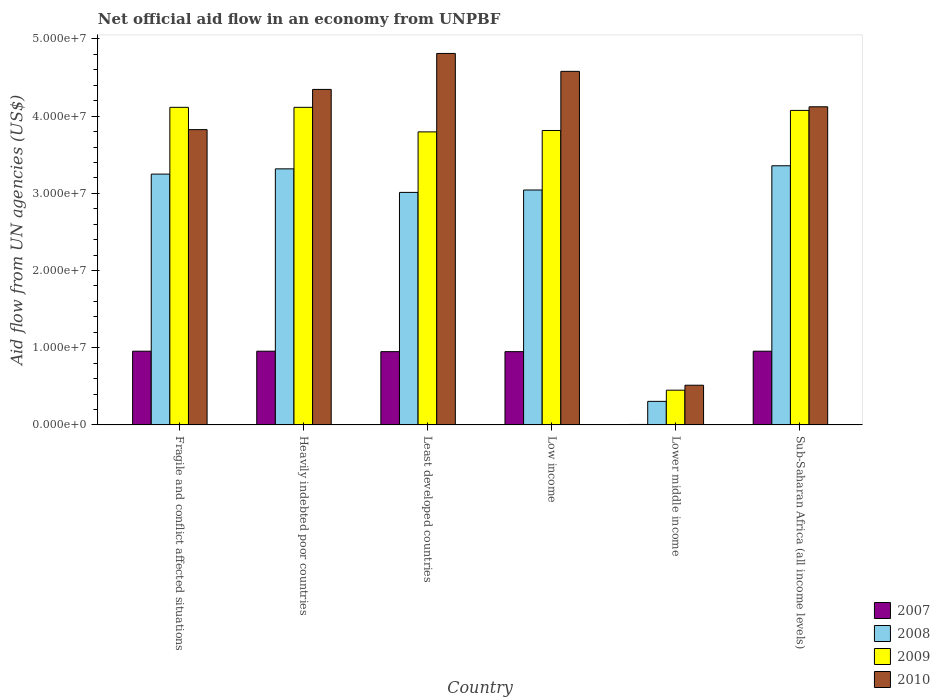Are the number of bars on each tick of the X-axis equal?
Your response must be concise. Yes. How many bars are there on the 5th tick from the left?
Keep it short and to the point. 4. How many bars are there on the 5th tick from the right?
Offer a very short reply. 4. What is the label of the 2nd group of bars from the left?
Your answer should be compact. Heavily indebted poor countries. In how many cases, is the number of bars for a given country not equal to the number of legend labels?
Provide a succinct answer. 0. What is the net official aid flow in 2007 in Sub-Saharan Africa (all income levels)?
Offer a terse response. 9.55e+06. Across all countries, what is the maximum net official aid flow in 2010?
Make the answer very short. 4.81e+07. Across all countries, what is the minimum net official aid flow in 2008?
Your answer should be very brief. 3.05e+06. In which country was the net official aid flow in 2010 maximum?
Keep it short and to the point. Least developed countries. In which country was the net official aid flow in 2010 minimum?
Ensure brevity in your answer.  Lower middle income. What is the total net official aid flow in 2010 in the graph?
Offer a very short reply. 2.22e+08. What is the difference between the net official aid flow in 2010 in Fragile and conflict affected situations and that in Lower middle income?
Your response must be concise. 3.31e+07. What is the difference between the net official aid flow in 2010 in Sub-Saharan Africa (all income levels) and the net official aid flow in 2007 in Lower middle income?
Your answer should be very brief. 4.12e+07. What is the average net official aid flow in 2010 per country?
Your answer should be very brief. 3.70e+07. What is the difference between the net official aid flow of/in 2009 and net official aid flow of/in 2008 in Sub-Saharan Africa (all income levels)?
Your response must be concise. 7.17e+06. What is the ratio of the net official aid flow in 2008 in Heavily indebted poor countries to that in Least developed countries?
Ensure brevity in your answer.  1.1. Is the net official aid flow in 2008 in Low income less than that in Sub-Saharan Africa (all income levels)?
Your response must be concise. Yes. Is the difference between the net official aid flow in 2009 in Fragile and conflict affected situations and Least developed countries greater than the difference between the net official aid flow in 2008 in Fragile and conflict affected situations and Least developed countries?
Keep it short and to the point. Yes. What is the difference between the highest and the second highest net official aid flow in 2010?
Give a very brief answer. 2.32e+06. What is the difference between the highest and the lowest net official aid flow in 2008?
Offer a very short reply. 3.05e+07. Is it the case that in every country, the sum of the net official aid flow in 2007 and net official aid flow in 2008 is greater than the sum of net official aid flow in 2010 and net official aid flow in 2009?
Make the answer very short. No. Is it the case that in every country, the sum of the net official aid flow in 2010 and net official aid flow in 2008 is greater than the net official aid flow in 2009?
Provide a succinct answer. Yes. Are all the bars in the graph horizontal?
Your response must be concise. No. Are the values on the major ticks of Y-axis written in scientific E-notation?
Your answer should be compact. Yes. Does the graph contain any zero values?
Ensure brevity in your answer.  No. Where does the legend appear in the graph?
Provide a succinct answer. Bottom right. What is the title of the graph?
Offer a terse response. Net official aid flow in an economy from UNPBF. Does "1983" appear as one of the legend labels in the graph?
Your response must be concise. No. What is the label or title of the X-axis?
Provide a short and direct response. Country. What is the label or title of the Y-axis?
Ensure brevity in your answer.  Aid flow from UN agencies (US$). What is the Aid flow from UN agencies (US$) of 2007 in Fragile and conflict affected situations?
Keep it short and to the point. 9.55e+06. What is the Aid flow from UN agencies (US$) in 2008 in Fragile and conflict affected situations?
Offer a very short reply. 3.25e+07. What is the Aid flow from UN agencies (US$) of 2009 in Fragile and conflict affected situations?
Offer a terse response. 4.11e+07. What is the Aid flow from UN agencies (US$) of 2010 in Fragile and conflict affected situations?
Give a very brief answer. 3.82e+07. What is the Aid flow from UN agencies (US$) in 2007 in Heavily indebted poor countries?
Provide a short and direct response. 9.55e+06. What is the Aid flow from UN agencies (US$) of 2008 in Heavily indebted poor countries?
Offer a very short reply. 3.32e+07. What is the Aid flow from UN agencies (US$) of 2009 in Heavily indebted poor countries?
Offer a very short reply. 4.11e+07. What is the Aid flow from UN agencies (US$) in 2010 in Heavily indebted poor countries?
Keep it short and to the point. 4.35e+07. What is the Aid flow from UN agencies (US$) of 2007 in Least developed countries?
Offer a terse response. 9.49e+06. What is the Aid flow from UN agencies (US$) of 2008 in Least developed countries?
Offer a very short reply. 3.01e+07. What is the Aid flow from UN agencies (US$) in 2009 in Least developed countries?
Offer a terse response. 3.80e+07. What is the Aid flow from UN agencies (US$) of 2010 in Least developed countries?
Offer a very short reply. 4.81e+07. What is the Aid flow from UN agencies (US$) of 2007 in Low income?
Give a very brief answer. 9.49e+06. What is the Aid flow from UN agencies (US$) in 2008 in Low income?
Provide a short and direct response. 3.04e+07. What is the Aid flow from UN agencies (US$) in 2009 in Low income?
Ensure brevity in your answer.  3.81e+07. What is the Aid flow from UN agencies (US$) in 2010 in Low income?
Provide a short and direct response. 4.58e+07. What is the Aid flow from UN agencies (US$) in 2008 in Lower middle income?
Your answer should be compact. 3.05e+06. What is the Aid flow from UN agencies (US$) in 2009 in Lower middle income?
Provide a succinct answer. 4.50e+06. What is the Aid flow from UN agencies (US$) in 2010 in Lower middle income?
Your answer should be compact. 5.14e+06. What is the Aid flow from UN agencies (US$) of 2007 in Sub-Saharan Africa (all income levels)?
Your answer should be compact. 9.55e+06. What is the Aid flow from UN agencies (US$) of 2008 in Sub-Saharan Africa (all income levels)?
Provide a succinct answer. 3.36e+07. What is the Aid flow from UN agencies (US$) in 2009 in Sub-Saharan Africa (all income levels)?
Provide a short and direct response. 4.07e+07. What is the Aid flow from UN agencies (US$) of 2010 in Sub-Saharan Africa (all income levels)?
Your answer should be compact. 4.12e+07. Across all countries, what is the maximum Aid flow from UN agencies (US$) of 2007?
Offer a very short reply. 9.55e+06. Across all countries, what is the maximum Aid flow from UN agencies (US$) of 2008?
Make the answer very short. 3.36e+07. Across all countries, what is the maximum Aid flow from UN agencies (US$) in 2009?
Your answer should be compact. 4.11e+07. Across all countries, what is the maximum Aid flow from UN agencies (US$) in 2010?
Your answer should be compact. 4.81e+07. Across all countries, what is the minimum Aid flow from UN agencies (US$) in 2007?
Ensure brevity in your answer.  6.00e+04. Across all countries, what is the minimum Aid flow from UN agencies (US$) of 2008?
Make the answer very short. 3.05e+06. Across all countries, what is the minimum Aid flow from UN agencies (US$) of 2009?
Your response must be concise. 4.50e+06. Across all countries, what is the minimum Aid flow from UN agencies (US$) in 2010?
Your answer should be very brief. 5.14e+06. What is the total Aid flow from UN agencies (US$) in 2007 in the graph?
Make the answer very short. 4.77e+07. What is the total Aid flow from UN agencies (US$) of 2008 in the graph?
Provide a short and direct response. 1.63e+08. What is the total Aid flow from UN agencies (US$) in 2009 in the graph?
Ensure brevity in your answer.  2.04e+08. What is the total Aid flow from UN agencies (US$) of 2010 in the graph?
Offer a very short reply. 2.22e+08. What is the difference between the Aid flow from UN agencies (US$) in 2007 in Fragile and conflict affected situations and that in Heavily indebted poor countries?
Your response must be concise. 0. What is the difference between the Aid flow from UN agencies (US$) of 2008 in Fragile and conflict affected situations and that in Heavily indebted poor countries?
Offer a terse response. -6.80e+05. What is the difference between the Aid flow from UN agencies (US$) of 2010 in Fragile and conflict affected situations and that in Heavily indebted poor countries?
Make the answer very short. -5.21e+06. What is the difference between the Aid flow from UN agencies (US$) of 2008 in Fragile and conflict affected situations and that in Least developed countries?
Provide a short and direct response. 2.37e+06. What is the difference between the Aid flow from UN agencies (US$) in 2009 in Fragile and conflict affected situations and that in Least developed countries?
Offer a terse response. 3.18e+06. What is the difference between the Aid flow from UN agencies (US$) of 2010 in Fragile and conflict affected situations and that in Least developed countries?
Your answer should be compact. -9.87e+06. What is the difference between the Aid flow from UN agencies (US$) in 2008 in Fragile and conflict affected situations and that in Low income?
Make the answer very short. 2.06e+06. What is the difference between the Aid flow from UN agencies (US$) in 2010 in Fragile and conflict affected situations and that in Low income?
Provide a short and direct response. -7.55e+06. What is the difference between the Aid flow from UN agencies (US$) of 2007 in Fragile and conflict affected situations and that in Lower middle income?
Provide a succinct answer. 9.49e+06. What is the difference between the Aid flow from UN agencies (US$) in 2008 in Fragile and conflict affected situations and that in Lower middle income?
Keep it short and to the point. 2.94e+07. What is the difference between the Aid flow from UN agencies (US$) in 2009 in Fragile and conflict affected situations and that in Lower middle income?
Ensure brevity in your answer.  3.66e+07. What is the difference between the Aid flow from UN agencies (US$) in 2010 in Fragile and conflict affected situations and that in Lower middle income?
Your answer should be compact. 3.31e+07. What is the difference between the Aid flow from UN agencies (US$) of 2007 in Fragile and conflict affected situations and that in Sub-Saharan Africa (all income levels)?
Keep it short and to the point. 0. What is the difference between the Aid flow from UN agencies (US$) in 2008 in Fragile and conflict affected situations and that in Sub-Saharan Africa (all income levels)?
Offer a very short reply. -1.08e+06. What is the difference between the Aid flow from UN agencies (US$) of 2009 in Fragile and conflict affected situations and that in Sub-Saharan Africa (all income levels)?
Your response must be concise. 4.00e+05. What is the difference between the Aid flow from UN agencies (US$) of 2010 in Fragile and conflict affected situations and that in Sub-Saharan Africa (all income levels)?
Your response must be concise. -2.96e+06. What is the difference between the Aid flow from UN agencies (US$) of 2008 in Heavily indebted poor countries and that in Least developed countries?
Give a very brief answer. 3.05e+06. What is the difference between the Aid flow from UN agencies (US$) of 2009 in Heavily indebted poor countries and that in Least developed countries?
Offer a very short reply. 3.18e+06. What is the difference between the Aid flow from UN agencies (US$) of 2010 in Heavily indebted poor countries and that in Least developed countries?
Ensure brevity in your answer.  -4.66e+06. What is the difference between the Aid flow from UN agencies (US$) in 2008 in Heavily indebted poor countries and that in Low income?
Keep it short and to the point. 2.74e+06. What is the difference between the Aid flow from UN agencies (US$) in 2010 in Heavily indebted poor countries and that in Low income?
Keep it short and to the point. -2.34e+06. What is the difference between the Aid flow from UN agencies (US$) of 2007 in Heavily indebted poor countries and that in Lower middle income?
Offer a very short reply. 9.49e+06. What is the difference between the Aid flow from UN agencies (US$) of 2008 in Heavily indebted poor countries and that in Lower middle income?
Make the answer very short. 3.01e+07. What is the difference between the Aid flow from UN agencies (US$) of 2009 in Heavily indebted poor countries and that in Lower middle income?
Provide a succinct answer. 3.66e+07. What is the difference between the Aid flow from UN agencies (US$) in 2010 in Heavily indebted poor countries and that in Lower middle income?
Provide a succinct answer. 3.83e+07. What is the difference between the Aid flow from UN agencies (US$) of 2008 in Heavily indebted poor countries and that in Sub-Saharan Africa (all income levels)?
Offer a terse response. -4.00e+05. What is the difference between the Aid flow from UN agencies (US$) in 2009 in Heavily indebted poor countries and that in Sub-Saharan Africa (all income levels)?
Keep it short and to the point. 4.00e+05. What is the difference between the Aid flow from UN agencies (US$) in 2010 in Heavily indebted poor countries and that in Sub-Saharan Africa (all income levels)?
Your response must be concise. 2.25e+06. What is the difference between the Aid flow from UN agencies (US$) in 2008 in Least developed countries and that in Low income?
Give a very brief answer. -3.10e+05. What is the difference between the Aid flow from UN agencies (US$) of 2009 in Least developed countries and that in Low income?
Ensure brevity in your answer.  -1.80e+05. What is the difference between the Aid flow from UN agencies (US$) of 2010 in Least developed countries and that in Low income?
Ensure brevity in your answer.  2.32e+06. What is the difference between the Aid flow from UN agencies (US$) of 2007 in Least developed countries and that in Lower middle income?
Ensure brevity in your answer.  9.43e+06. What is the difference between the Aid flow from UN agencies (US$) of 2008 in Least developed countries and that in Lower middle income?
Give a very brief answer. 2.71e+07. What is the difference between the Aid flow from UN agencies (US$) of 2009 in Least developed countries and that in Lower middle income?
Ensure brevity in your answer.  3.35e+07. What is the difference between the Aid flow from UN agencies (US$) in 2010 in Least developed countries and that in Lower middle income?
Offer a terse response. 4.30e+07. What is the difference between the Aid flow from UN agencies (US$) in 2008 in Least developed countries and that in Sub-Saharan Africa (all income levels)?
Your answer should be very brief. -3.45e+06. What is the difference between the Aid flow from UN agencies (US$) of 2009 in Least developed countries and that in Sub-Saharan Africa (all income levels)?
Ensure brevity in your answer.  -2.78e+06. What is the difference between the Aid flow from UN agencies (US$) in 2010 in Least developed countries and that in Sub-Saharan Africa (all income levels)?
Your answer should be very brief. 6.91e+06. What is the difference between the Aid flow from UN agencies (US$) in 2007 in Low income and that in Lower middle income?
Your answer should be very brief. 9.43e+06. What is the difference between the Aid flow from UN agencies (US$) in 2008 in Low income and that in Lower middle income?
Offer a very short reply. 2.74e+07. What is the difference between the Aid flow from UN agencies (US$) of 2009 in Low income and that in Lower middle income?
Your answer should be very brief. 3.36e+07. What is the difference between the Aid flow from UN agencies (US$) of 2010 in Low income and that in Lower middle income?
Ensure brevity in your answer.  4.07e+07. What is the difference between the Aid flow from UN agencies (US$) of 2008 in Low income and that in Sub-Saharan Africa (all income levels)?
Provide a short and direct response. -3.14e+06. What is the difference between the Aid flow from UN agencies (US$) in 2009 in Low income and that in Sub-Saharan Africa (all income levels)?
Ensure brevity in your answer.  -2.60e+06. What is the difference between the Aid flow from UN agencies (US$) of 2010 in Low income and that in Sub-Saharan Africa (all income levels)?
Ensure brevity in your answer.  4.59e+06. What is the difference between the Aid flow from UN agencies (US$) in 2007 in Lower middle income and that in Sub-Saharan Africa (all income levels)?
Give a very brief answer. -9.49e+06. What is the difference between the Aid flow from UN agencies (US$) in 2008 in Lower middle income and that in Sub-Saharan Africa (all income levels)?
Ensure brevity in your answer.  -3.05e+07. What is the difference between the Aid flow from UN agencies (US$) in 2009 in Lower middle income and that in Sub-Saharan Africa (all income levels)?
Provide a succinct answer. -3.62e+07. What is the difference between the Aid flow from UN agencies (US$) of 2010 in Lower middle income and that in Sub-Saharan Africa (all income levels)?
Keep it short and to the point. -3.61e+07. What is the difference between the Aid flow from UN agencies (US$) in 2007 in Fragile and conflict affected situations and the Aid flow from UN agencies (US$) in 2008 in Heavily indebted poor countries?
Ensure brevity in your answer.  -2.36e+07. What is the difference between the Aid flow from UN agencies (US$) of 2007 in Fragile and conflict affected situations and the Aid flow from UN agencies (US$) of 2009 in Heavily indebted poor countries?
Provide a short and direct response. -3.16e+07. What is the difference between the Aid flow from UN agencies (US$) in 2007 in Fragile and conflict affected situations and the Aid flow from UN agencies (US$) in 2010 in Heavily indebted poor countries?
Ensure brevity in your answer.  -3.39e+07. What is the difference between the Aid flow from UN agencies (US$) of 2008 in Fragile and conflict affected situations and the Aid flow from UN agencies (US$) of 2009 in Heavily indebted poor countries?
Provide a succinct answer. -8.65e+06. What is the difference between the Aid flow from UN agencies (US$) of 2008 in Fragile and conflict affected situations and the Aid flow from UN agencies (US$) of 2010 in Heavily indebted poor countries?
Ensure brevity in your answer.  -1.10e+07. What is the difference between the Aid flow from UN agencies (US$) of 2009 in Fragile and conflict affected situations and the Aid flow from UN agencies (US$) of 2010 in Heavily indebted poor countries?
Make the answer very short. -2.32e+06. What is the difference between the Aid flow from UN agencies (US$) of 2007 in Fragile and conflict affected situations and the Aid flow from UN agencies (US$) of 2008 in Least developed countries?
Ensure brevity in your answer.  -2.06e+07. What is the difference between the Aid flow from UN agencies (US$) in 2007 in Fragile and conflict affected situations and the Aid flow from UN agencies (US$) in 2009 in Least developed countries?
Ensure brevity in your answer.  -2.84e+07. What is the difference between the Aid flow from UN agencies (US$) of 2007 in Fragile and conflict affected situations and the Aid flow from UN agencies (US$) of 2010 in Least developed countries?
Provide a short and direct response. -3.86e+07. What is the difference between the Aid flow from UN agencies (US$) of 2008 in Fragile and conflict affected situations and the Aid flow from UN agencies (US$) of 2009 in Least developed countries?
Provide a succinct answer. -5.47e+06. What is the difference between the Aid flow from UN agencies (US$) in 2008 in Fragile and conflict affected situations and the Aid flow from UN agencies (US$) in 2010 in Least developed countries?
Your response must be concise. -1.56e+07. What is the difference between the Aid flow from UN agencies (US$) of 2009 in Fragile and conflict affected situations and the Aid flow from UN agencies (US$) of 2010 in Least developed countries?
Offer a very short reply. -6.98e+06. What is the difference between the Aid flow from UN agencies (US$) in 2007 in Fragile and conflict affected situations and the Aid flow from UN agencies (US$) in 2008 in Low income?
Provide a succinct answer. -2.09e+07. What is the difference between the Aid flow from UN agencies (US$) of 2007 in Fragile and conflict affected situations and the Aid flow from UN agencies (US$) of 2009 in Low income?
Offer a very short reply. -2.86e+07. What is the difference between the Aid flow from UN agencies (US$) of 2007 in Fragile and conflict affected situations and the Aid flow from UN agencies (US$) of 2010 in Low income?
Provide a succinct answer. -3.62e+07. What is the difference between the Aid flow from UN agencies (US$) of 2008 in Fragile and conflict affected situations and the Aid flow from UN agencies (US$) of 2009 in Low income?
Your response must be concise. -5.65e+06. What is the difference between the Aid flow from UN agencies (US$) in 2008 in Fragile and conflict affected situations and the Aid flow from UN agencies (US$) in 2010 in Low income?
Keep it short and to the point. -1.33e+07. What is the difference between the Aid flow from UN agencies (US$) in 2009 in Fragile and conflict affected situations and the Aid flow from UN agencies (US$) in 2010 in Low income?
Your answer should be compact. -4.66e+06. What is the difference between the Aid flow from UN agencies (US$) of 2007 in Fragile and conflict affected situations and the Aid flow from UN agencies (US$) of 2008 in Lower middle income?
Make the answer very short. 6.50e+06. What is the difference between the Aid flow from UN agencies (US$) in 2007 in Fragile and conflict affected situations and the Aid flow from UN agencies (US$) in 2009 in Lower middle income?
Offer a terse response. 5.05e+06. What is the difference between the Aid flow from UN agencies (US$) of 2007 in Fragile and conflict affected situations and the Aid flow from UN agencies (US$) of 2010 in Lower middle income?
Keep it short and to the point. 4.41e+06. What is the difference between the Aid flow from UN agencies (US$) of 2008 in Fragile and conflict affected situations and the Aid flow from UN agencies (US$) of 2009 in Lower middle income?
Provide a succinct answer. 2.80e+07. What is the difference between the Aid flow from UN agencies (US$) of 2008 in Fragile and conflict affected situations and the Aid flow from UN agencies (US$) of 2010 in Lower middle income?
Offer a terse response. 2.74e+07. What is the difference between the Aid flow from UN agencies (US$) in 2009 in Fragile and conflict affected situations and the Aid flow from UN agencies (US$) in 2010 in Lower middle income?
Your answer should be compact. 3.60e+07. What is the difference between the Aid flow from UN agencies (US$) of 2007 in Fragile and conflict affected situations and the Aid flow from UN agencies (US$) of 2008 in Sub-Saharan Africa (all income levels)?
Offer a terse response. -2.40e+07. What is the difference between the Aid flow from UN agencies (US$) of 2007 in Fragile and conflict affected situations and the Aid flow from UN agencies (US$) of 2009 in Sub-Saharan Africa (all income levels)?
Give a very brief answer. -3.12e+07. What is the difference between the Aid flow from UN agencies (US$) in 2007 in Fragile and conflict affected situations and the Aid flow from UN agencies (US$) in 2010 in Sub-Saharan Africa (all income levels)?
Ensure brevity in your answer.  -3.17e+07. What is the difference between the Aid flow from UN agencies (US$) of 2008 in Fragile and conflict affected situations and the Aid flow from UN agencies (US$) of 2009 in Sub-Saharan Africa (all income levels)?
Give a very brief answer. -8.25e+06. What is the difference between the Aid flow from UN agencies (US$) in 2008 in Fragile and conflict affected situations and the Aid flow from UN agencies (US$) in 2010 in Sub-Saharan Africa (all income levels)?
Give a very brief answer. -8.72e+06. What is the difference between the Aid flow from UN agencies (US$) in 2007 in Heavily indebted poor countries and the Aid flow from UN agencies (US$) in 2008 in Least developed countries?
Offer a very short reply. -2.06e+07. What is the difference between the Aid flow from UN agencies (US$) in 2007 in Heavily indebted poor countries and the Aid flow from UN agencies (US$) in 2009 in Least developed countries?
Your answer should be very brief. -2.84e+07. What is the difference between the Aid flow from UN agencies (US$) of 2007 in Heavily indebted poor countries and the Aid flow from UN agencies (US$) of 2010 in Least developed countries?
Provide a succinct answer. -3.86e+07. What is the difference between the Aid flow from UN agencies (US$) of 2008 in Heavily indebted poor countries and the Aid flow from UN agencies (US$) of 2009 in Least developed countries?
Offer a very short reply. -4.79e+06. What is the difference between the Aid flow from UN agencies (US$) of 2008 in Heavily indebted poor countries and the Aid flow from UN agencies (US$) of 2010 in Least developed countries?
Make the answer very short. -1.50e+07. What is the difference between the Aid flow from UN agencies (US$) of 2009 in Heavily indebted poor countries and the Aid flow from UN agencies (US$) of 2010 in Least developed countries?
Your answer should be compact. -6.98e+06. What is the difference between the Aid flow from UN agencies (US$) of 2007 in Heavily indebted poor countries and the Aid flow from UN agencies (US$) of 2008 in Low income?
Offer a terse response. -2.09e+07. What is the difference between the Aid flow from UN agencies (US$) in 2007 in Heavily indebted poor countries and the Aid flow from UN agencies (US$) in 2009 in Low income?
Offer a terse response. -2.86e+07. What is the difference between the Aid flow from UN agencies (US$) of 2007 in Heavily indebted poor countries and the Aid flow from UN agencies (US$) of 2010 in Low income?
Provide a short and direct response. -3.62e+07. What is the difference between the Aid flow from UN agencies (US$) in 2008 in Heavily indebted poor countries and the Aid flow from UN agencies (US$) in 2009 in Low income?
Your answer should be compact. -4.97e+06. What is the difference between the Aid flow from UN agencies (US$) of 2008 in Heavily indebted poor countries and the Aid flow from UN agencies (US$) of 2010 in Low income?
Your response must be concise. -1.26e+07. What is the difference between the Aid flow from UN agencies (US$) of 2009 in Heavily indebted poor countries and the Aid flow from UN agencies (US$) of 2010 in Low income?
Your response must be concise. -4.66e+06. What is the difference between the Aid flow from UN agencies (US$) in 2007 in Heavily indebted poor countries and the Aid flow from UN agencies (US$) in 2008 in Lower middle income?
Make the answer very short. 6.50e+06. What is the difference between the Aid flow from UN agencies (US$) of 2007 in Heavily indebted poor countries and the Aid flow from UN agencies (US$) of 2009 in Lower middle income?
Your response must be concise. 5.05e+06. What is the difference between the Aid flow from UN agencies (US$) in 2007 in Heavily indebted poor countries and the Aid flow from UN agencies (US$) in 2010 in Lower middle income?
Offer a very short reply. 4.41e+06. What is the difference between the Aid flow from UN agencies (US$) in 2008 in Heavily indebted poor countries and the Aid flow from UN agencies (US$) in 2009 in Lower middle income?
Offer a very short reply. 2.87e+07. What is the difference between the Aid flow from UN agencies (US$) of 2008 in Heavily indebted poor countries and the Aid flow from UN agencies (US$) of 2010 in Lower middle income?
Provide a succinct answer. 2.80e+07. What is the difference between the Aid flow from UN agencies (US$) in 2009 in Heavily indebted poor countries and the Aid flow from UN agencies (US$) in 2010 in Lower middle income?
Make the answer very short. 3.60e+07. What is the difference between the Aid flow from UN agencies (US$) of 2007 in Heavily indebted poor countries and the Aid flow from UN agencies (US$) of 2008 in Sub-Saharan Africa (all income levels)?
Offer a terse response. -2.40e+07. What is the difference between the Aid flow from UN agencies (US$) in 2007 in Heavily indebted poor countries and the Aid flow from UN agencies (US$) in 2009 in Sub-Saharan Africa (all income levels)?
Provide a succinct answer. -3.12e+07. What is the difference between the Aid flow from UN agencies (US$) in 2007 in Heavily indebted poor countries and the Aid flow from UN agencies (US$) in 2010 in Sub-Saharan Africa (all income levels)?
Give a very brief answer. -3.17e+07. What is the difference between the Aid flow from UN agencies (US$) of 2008 in Heavily indebted poor countries and the Aid flow from UN agencies (US$) of 2009 in Sub-Saharan Africa (all income levels)?
Keep it short and to the point. -7.57e+06. What is the difference between the Aid flow from UN agencies (US$) of 2008 in Heavily indebted poor countries and the Aid flow from UN agencies (US$) of 2010 in Sub-Saharan Africa (all income levels)?
Keep it short and to the point. -8.04e+06. What is the difference between the Aid flow from UN agencies (US$) in 2007 in Least developed countries and the Aid flow from UN agencies (US$) in 2008 in Low income?
Offer a terse response. -2.09e+07. What is the difference between the Aid flow from UN agencies (US$) in 2007 in Least developed countries and the Aid flow from UN agencies (US$) in 2009 in Low income?
Make the answer very short. -2.86e+07. What is the difference between the Aid flow from UN agencies (US$) in 2007 in Least developed countries and the Aid flow from UN agencies (US$) in 2010 in Low income?
Ensure brevity in your answer.  -3.63e+07. What is the difference between the Aid flow from UN agencies (US$) of 2008 in Least developed countries and the Aid flow from UN agencies (US$) of 2009 in Low income?
Provide a succinct answer. -8.02e+06. What is the difference between the Aid flow from UN agencies (US$) in 2008 in Least developed countries and the Aid flow from UN agencies (US$) in 2010 in Low income?
Keep it short and to the point. -1.57e+07. What is the difference between the Aid flow from UN agencies (US$) of 2009 in Least developed countries and the Aid flow from UN agencies (US$) of 2010 in Low income?
Provide a short and direct response. -7.84e+06. What is the difference between the Aid flow from UN agencies (US$) of 2007 in Least developed countries and the Aid flow from UN agencies (US$) of 2008 in Lower middle income?
Offer a terse response. 6.44e+06. What is the difference between the Aid flow from UN agencies (US$) of 2007 in Least developed countries and the Aid flow from UN agencies (US$) of 2009 in Lower middle income?
Offer a very short reply. 4.99e+06. What is the difference between the Aid flow from UN agencies (US$) in 2007 in Least developed countries and the Aid flow from UN agencies (US$) in 2010 in Lower middle income?
Your answer should be very brief. 4.35e+06. What is the difference between the Aid flow from UN agencies (US$) of 2008 in Least developed countries and the Aid flow from UN agencies (US$) of 2009 in Lower middle income?
Ensure brevity in your answer.  2.56e+07. What is the difference between the Aid flow from UN agencies (US$) of 2008 in Least developed countries and the Aid flow from UN agencies (US$) of 2010 in Lower middle income?
Keep it short and to the point. 2.50e+07. What is the difference between the Aid flow from UN agencies (US$) in 2009 in Least developed countries and the Aid flow from UN agencies (US$) in 2010 in Lower middle income?
Give a very brief answer. 3.28e+07. What is the difference between the Aid flow from UN agencies (US$) in 2007 in Least developed countries and the Aid flow from UN agencies (US$) in 2008 in Sub-Saharan Africa (all income levels)?
Offer a very short reply. -2.41e+07. What is the difference between the Aid flow from UN agencies (US$) of 2007 in Least developed countries and the Aid flow from UN agencies (US$) of 2009 in Sub-Saharan Africa (all income levels)?
Ensure brevity in your answer.  -3.12e+07. What is the difference between the Aid flow from UN agencies (US$) in 2007 in Least developed countries and the Aid flow from UN agencies (US$) in 2010 in Sub-Saharan Africa (all income levels)?
Your answer should be very brief. -3.17e+07. What is the difference between the Aid flow from UN agencies (US$) in 2008 in Least developed countries and the Aid flow from UN agencies (US$) in 2009 in Sub-Saharan Africa (all income levels)?
Your answer should be compact. -1.06e+07. What is the difference between the Aid flow from UN agencies (US$) in 2008 in Least developed countries and the Aid flow from UN agencies (US$) in 2010 in Sub-Saharan Africa (all income levels)?
Ensure brevity in your answer.  -1.11e+07. What is the difference between the Aid flow from UN agencies (US$) of 2009 in Least developed countries and the Aid flow from UN agencies (US$) of 2010 in Sub-Saharan Africa (all income levels)?
Provide a short and direct response. -3.25e+06. What is the difference between the Aid flow from UN agencies (US$) of 2007 in Low income and the Aid flow from UN agencies (US$) of 2008 in Lower middle income?
Ensure brevity in your answer.  6.44e+06. What is the difference between the Aid flow from UN agencies (US$) of 2007 in Low income and the Aid flow from UN agencies (US$) of 2009 in Lower middle income?
Your answer should be compact. 4.99e+06. What is the difference between the Aid flow from UN agencies (US$) in 2007 in Low income and the Aid flow from UN agencies (US$) in 2010 in Lower middle income?
Your response must be concise. 4.35e+06. What is the difference between the Aid flow from UN agencies (US$) in 2008 in Low income and the Aid flow from UN agencies (US$) in 2009 in Lower middle income?
Keep it short and to the point. 2.59e+07. What is the difference between the Aid flow from UN agencies (US$) in 2008 in Low income and the Aid flow from UN agencies (US$) in 2010 in Lower middle income?
Offer a terse response. 2.53e+07. What is the difference between the Aid flow from UN agencies (US$) in 2009 in Low income and the Aid flow from UN agencies (US$) in 2010 in Lower middle income?
Make the answer very short. 3.30e+07. What is the difference between the Aid flow from UN agencies (US$) in 2007 in Low income and the Aid flow from UN agencies (US$) in 2008 in Sub-Saharan Africa (all income levels)?
Your answer should be very brief. -2.41e+07. What is the difference between the Aid flow from UN agencies (US$) in 2007 in Low income and the Aid flow from UN agencies (US$) in 2009 in Sub-Saharan Africa (all income levels)?
Give a very brief answer. -3.12e+07. What is the difference between the Aid flow from UN agencies (US$) in 2007 in Low income and the Aid flow from UN agencies (US$) in 2010 in Sub-Saharan Africa (all income levels)?
Offer a very short reply. -3.17e+07. What is the difference between the Aid flow from UN agencies (US$) of 2008 in Low income and the Aid flow from UN agencies (US$) of 2009 in Sub-Saharan Africa (all income levels)?
Provide a short and direct response. -1.03e+07. What is the difference between the Aid flow from UN agencies (US$) of 2008 in Low income and the Aid flow from UN agencies (US$) of 2010 in Sub-Saharan Africa (all income levels)?
Make the answer very short. -1.08e+07. What is the difference between the Aid flow from UN agencies (US$) of 2009 in Low income and the Aid flow from UN agencies (US$) of 2010 in Sub-Saharan Africa (all income levels)?
Keep it short and to the point. -3.07e+06. What is the difference between the Aid flow from UN agencies (US$) of 2007 in Lower middle income and the Aid flow from UN agencies (US$) of 2008 in Sub-Saharan Africa (all income levels)?
Ensure brevity in your answer.  -3.35e+07. What is the difference between the Aid flow from UN agencies (US$) of 2007 in Lower middle income and the Aid flow from UN agencies (US$) of 2009 in Sub-Saharan Africa (all income levels)?
Offer a very short reply. -4.07e+07. What is the difference between the Aid flow from UN agencies (US$) of 2007 in Lower middle income and the Aid flow from UN agencies (US$) of 2010 in Sub-Saharan Africa (all income levels)?
Make the answer very short. -4.12e+07. What is the difference between the Aid flow from UN agencies (US$) in 2008 in Lower middle income and the Aid flow from UN agencies (US$) in 2009 in Sub-Saharan Africa (all income levels)?
Give a very brief answer. -3.77e+07. What is the difference between the Aid flow from UN agencies (US$) in 2008 in Lower middle income and the Aid flow from UN agencies (US$) in 2010 in Sub-Saharan Africa (all income levels)?
Your response must be concise. -3.82e+07. What is the difference between the Aid flow from UN agencies (US$) in 2009 in Lower middle income and the Aid flow from UN agencies (US$) in 2010 in Sub-Saharan Africa (all income levels)?
Offer a terse response. -3.67e+07. What is the average Aid flow from UN agencies (US$) in 2007 per country?
Your answer should be compact. 7.95e+06. What is the average Aid flow from UN agencies (US$) of 2008 per country?
Your response must be concise. 2.71e+07. What is the average Aid flow from UN agencies (US$) in 2009 per country?
Your answer should be compact. 3.39e+07. What is the average Aid flow from UN agencies (US$) of 2010 per country?
Provide a succinct answer. 3.70e+07. What is the difference between the Aid flow from UN agencies (US$) in 2007 and Aid flow from UN agencies (US$) in 2008 in Fragile and conflict affected situations?
Offer a terse response. -2.29e+07. What is the difference between the Aid flow from UN agencies (US$) in 2007 and Aid flow from UN agencies (US$) in 2009 in Fragile and conflict affected situations?
Provide a short and direct response. -3.16e+07. What is the difference between the Aid flow from UN agencies (US$) in 2007 and Aid flow from UN agencies (US$) in 2010 in Fragile and conflict affected situations?
Provide a short and direct response. -2.87e+07. What is the difference between the Aid flow from UN agencies (US$) of 2008 and Aid flow from UN agencies (US$) of 2009 in Fragile and conflict affected situations?
Give a very brief answer. -8.65e+06. What is the difference between the Aid flow from UN agencies (US$) of 2008 and Aid flow from UN agencies (US$) of 2010 in Fragile and conflict affected situations?
Offer a very short reply. -5.76e+06. What is the difference between the Aid flow from UN agencies (US$) in 2009 and Aid flow from UN agencies (US$) in 2010 in Fragile and conflict affected situations?
Offer a terse response. 2.89e+06. What is the difference between the Aid flow from UN agencies (US$) of 2007 and Aid flow from UN agencies (US$) of 2008 in Heavily indebted poor countries?
Make the answer very short. -2.36e+07. What is the difference between the Aid flow from UN agencies (US$) of 2007 and Aid flow from UN agencies (US$) of 2009 in Heavily indebted poor countries?
Offer a terse response. -3.16e+07. What is the difference between the Aid flow from UN agencies (US$) of 2007 and Aid flow from UN agencies (US$) of 2010 in Heavily indebted poor countries?
Provide a succinct answer. -3.39e+07. What is the difference between the Aid flow from UN agencies (US$) of 2008 and Aid flow from UN agencies (US$) of 2009 in Heavily indebted poor countries?
Your answer should be compact. -7.97e+06. What is the difference between the Aid flow from UN agencies (US$) of 2008 and Aid flow from UN agencies (US$) of 2010 in Heavily indebted poor countries?
Provide a succinct answer. -1.03e+07. What is the difference between the Aid flow from UN agencies (US$) in 2009 and Aid flow from UN agencies (US$) in 2010 in Heavily indebted poor countries?
Your response must be concise. -2.32e+06. What is the difference between the Aid flow from UN agencies (US$) of 2007 and Aid flow from UN agencies (US$) of 2008 in Least developed countries?
Your answer should be compact. -2.06e+07. What is the difference between the Aid flow from UN agencies (US$) of 2007 and Aid flow from UN agencies (US$) of 2009 in Least developed countries?
Your response must be concise. -2.85e+07. What is the difference between the Aid flow from UN agencies (US$) of 2007 and Aid flow from UN agencies (US$) of 2010 in Least developed countries?
Provide a short and direct response. -3.86e+07. What is the difference between the Aid flow from UN agencies (US$) of 2008 and Aid flow from UN agencies (US$) of 2009 in Least developed countries?
Provide a succinct answer. -7.84e+06. What is the difference between the Aid flow from UN agencies (US$) in 2008 and Aid flow from UN agencies (US$) in 2010 in Least developed countries?
Make the answer very short. -1.80e+07. What is the difference between the Aid flow from UN agencies (US$) in 2009 and Aid flow from UN agencies (US$) in 2010 in Least developed countries?
Your response must be concise. -1.02e+07. What is the difference between the Aid flow from UN agencies (US$) in 2007 and Aid flow from UN agencies (US$) in 2008 in Low income?
Your response must be concise. -2.09e+07. What is the difference between the Aid flow from UN agencies (US$) in 2007 and Aid flow from UN agencies (US$) in 2009 in Low income?
Provide a short and direct response. -2.86e+07. What is the difference between the Aid flow from UN agencies (US$) in 2007 and Aid flow from UN agencies (US$) in 2010 in Low income?
Offer a very short reply. -3.63e+07. What is the difference between the Aid flow from UN agencies (US$) of 2008 and Aid flow from UN agencies (US$) of 2009 in Low income?
Your response must be concise. -7.71e+06. What is the difference between the Aid flow from UN agencies (US$) in 2008 and Aid flow from UN agencies (US$) in 2010 in Low income?
Offer a terse response. -1.54e+07. What is the difference between the Aid flow from UN agencies (US$) of 2009 and Aid flow from UN agencies (US$) of 2010 in Low income?
Keep it short and to the point. -7.66e+06. What is the difference between the Aid flow from UN agencies (US$) in 2007 and Aid flow from UN agencies (US$) in 2008 in Lower middle income?
Provide a succinct answer. -2.99e+06. What is the difference between the Aid flow from UN agencies (US$) of 2007 and Aid flow from UN agencies (US$) of 2009 in Lower middle income?
Your answer should be very brief. -4.44e+06. What is the difference between the Aid flow from UN agencies (US$) in 2007 and Aid flow from UN agencies (US$) in 2010 in Lower middle income?
Your answer should be compact. -5.08e+06. What is the difference between the Aid flow from UN agencies (US$) of 2008 and Aid flow from UN agencies (US$) of 2009 in Lower middle income?
Make the answer very short. -1.45e+06. What is the difference between the Aid flow from UN agencies (US$) of 2008 and Aid flow from UN agencies (US$) of 2010 in Lower middle income?
Your answer should be compact. -2.09e+06. What is the difference between the Aid flow from UN agencies (US$) in 2009 and Aid flow from UN agencies (US$) in 2010 in Lower middle income?
Give a very brief answer. -6.40e+05. What is the difference between the Aid flow from UN agencies (US$) in 2007 and Aid flow from UN agencies (US$) in 2008 in Sub-Saharan Africa (all income levels)?
Ensure brevity in your answer.  -2.40e+07. What is the difference between the Aid flow from UN agencies (US$) of 2007 and Aid flow from UN agencies (US$) of 2009 in Sub-Saharan Africa (all income levels)?
Offer a very short reply. -3.12e+07. What is the difference between the Aid flow from UN agencies (US$) of 2007 and Aid flow from UN agencies (US$) of 2010 in Sub-Saharan Africa (all income levels)?
Ensure brevity in your answer.  -3.17e+07. What is the difference between the Aid flow from UN agencies (US$) in 2008 and Aid flow from UN agencies (US$) in 2009 in Sub-Saharan Africa (all income levels)?
Give a very brief answer. -7.17e+06. What is the difference between the Aid flow from UN agencies (US$) of 2008 and Aid flow from UN agencies (US$) of 2010 in Sub-Saharan Africa (all income levels)?
Offer a very short reply. -7.64e+06. What is the difference between the Aid flow from UN agencies (US$) of 2009 and Aid flow from UN agencies (US$) of 2010 in Sub-Saharan Africa (all income levels)?
Offer a terse response. -4.70e+05. What is the ratio of the Aid flow from UN agencies (US$) in 2007 in Fragile and conflict affected situations to that in Heavily indebted poor countries?
Offer a terse response. 1. What is the ratio of the Aid flow from UN agencies (US$) of 2008 in Fragile and conflict affected situations to that in Heavily indebted poor countries?
Give a very brief answer. 0.98. What is the ratio of the Aid flow from UN agencies (US$) in 2010 in Fragile and conflict affected situations to that in Heavily indebted poor countries?
Your answer should be very brief. 0.88. What is the ratio of the Aid flow from UN agencies (US$) of 2008 in Fragile and conflict affected situations to that in Least developed countries?
Your answer should be compact. 1.08. What is the ratio of the Aid flow from UN agencies (US$) of 2009 in Fragile and conflict affected situations to that in Least developed countries?
Give a very brief answer. 1.08. What is the ratio of the Aid flow from UN agencies (US$) in 2010 in Fragile and conflict affected situations to that in Least developed countries?
Make the answer very short. 0.79. What is the ratio of the Aid flow from UN agencies (US$) of 2008 in Fragile and conflict affected situations to that in Low income?
Offer a terse response. 1.07. What is the ratio of the Aid flow from UN agencies (US$) of 2009 in Fragile and conflict affected situations to that in Low income?
Offer a terse response. 1.08. What is the ratio of the Aid flow from UN agencies (US$) of 2010 in Fragile and conflict affected situations to that in Low income?
Offer a very short reply. 0.84. What is the ratio of the Aid flow from UN agencies (US$) of 2007 in Fragile and conflict affected situations to that in Lower middle income?
Provide a short and direct response. 159.17. What is the ratio of the Aid flow from UN agencies (US$) in 2008 in Fragile and conflict affected situations to that in Lower middle income?
Your response must be concise. 10.65. What is the ratio of the Aid flow from UN agencies (US$) in 2009 in Fragile and conflict affected situations to that in Lower middle income?
Ensure brevity in your answer.  9.14. What is the ratio of the Aid flow from UN agencies (US$) of 2010 in Fragile and conflict affected situations to that in Lower middle income?
Provide a short and direct response. 7.44. What is the ratio of the Aid flow from UN agencies (US$) of 2007 in Fragile and conflict affected situations to that in Sub-Saharan Africa (all income levels)?
Ensure brevity in your answer.  1. What is the ratio of the Aid flow from UN agencies (US$) of 2008 in Fragile and conflict affected situations to that in Sub-Saharan Africa (all income levels)?
Offer a very short reply. 0.97. What is the ratio of the Aid flow from UN agencies (US$) in 2009 in Fragile and conflict affected situations to that in Sub-Saharan Africa (all income levels)?
Give a very brief answer. 1.01. What is the ratio of the Aid flow from UN agencies (US$) of 2010 in Fragile and conflict affected situations to that in Sub-Saharan Africa (all income levels)?
Your response must be concise. 0.93. What is the ratio of the Aid flow from UN agencies (US$) of 2008 in Heavily indebted poor countries to that in Least developed countries?
Provide a succinct answer. 1.1. What is the ratio of the Aid flow from UN agencies (US$) of 2009 in Heavily indebted poor countries to that in Least developed countries?
Your answer should be very brief. 1.08. What is the ratio of the Aid flow from UN agencies (US$) in 2010 in Heavily indebted poor countries to that in Least developed countries?
Ensure brevity in your answer.  0.9. What is the ratio of the Aid flow from UN agencies (US$) of 2008 in Heavily indebted poor countries to that in Low income?
Your answer should be very brief. 1.09. What is the ratio of the Aid flow from UN agencies (US$) in 2009 in Heavily indebted poor countries to that in Low income?
Give a very brief answer. 1.08. What is the ratio of the Aid flow from UN agencies (US$) in 2010 in Heavily indebted poor countries to that in Low income?
Keep it short and to the point. 0.95. What is the ratio of the Aid flow from UN agencies (US$) of 2007 in Heavily indebted poor countries to that in Lower middle income?
Make the answer very short. 159.17. What is the ratio of the Aid flow from UN agencies (US$) in 2008 in Heavily indebted poor countries to that in Lower middle income?
Your answer should be very brief. 10.88. What is the ratio of the Aid flow from UN agencies (US$) of 2009 in Heavily indebted poor countries to that in Lower middle income?
Your answer should be very brief. 9.14. What is the ratio of the Aid flow from UN agencies (US$) of 2010 in Heavily indebted poor countries to that in Lower middle income?
Your answer should be compact. 8.46. What is the ratio of the Aid flow from UN agencies (US$) of 2008 in Heavily indebted poor countries to that in Sub-Saharan Africa (all income levels)?
Keep it short and to the point. 0.99. What is the ratio of the Aid flow from UN agencies (US$) of 2009 in Heavily indebted poor countries to that in Sub-Saharan Africa (all income levels)?
Keep it short and to the point. 1.01. What is the ratio of the Aid flow from UN agencies (US$) in 2010 in Heavily indebted poor countries to that in Sub-Saharan Africa (all income levels)?
Provide a succinct answer. 1.05. What is the ratio of the Aid flow from UN agencies (US$) in 2007 in Least developed countries to that in Low income?
Give a very brief answer. 1. What is the ratio of the Aid flow from UN agencies (US$) in 2008 in Least developed countries to that in Low income?
Your answer should be compact. 0.99. What is the ratio of the Aid flow from UN agencies (US$) of 2009 in Least developed countries to that in Low income?
Keep it short and to the point. 1. What is the ratio of the Aid flow from UN agencies (US$) of 2010 in Least developed countries to that in Low income?
Keep it short and to the point. 1.05. What is the ratio of the Aid flow from UN agencies (US$) of 2007 in Least developed countries to that in Lower middle income?
Offer a very short reply. 158.17. What is the ratio of the Aid flow from UN agencies (US$) in 2008 in Least developed countries to that in Lower middle income?
Your answer should be compact. 9.88. What is the ratio of the Aid flow from UN agencies (US$) in 2009 in Least developed countries to that in Lower middle income?
Your answer should be compact. 8.44. What is the ratio of the Aid flow from UN agencies (US$) of 2010 in Least developed countries to that in Lower middle income?
Offer a terse response. 9.36. What is the ratio of the Aid flow from UN agencies (US$) of 2007 in Least developed countries to that in Sub-Saharan Africa (all income levels)?
Your answer should be compact. 0.99. What is the ratio of the Aid flow from UN agencies (US$) in 2008 in Least developed countries to that in Sub-Saharan Africa (all income levels)?
Keep it short and to the point. 0.9. What is the ratio of the Aid flow from UN agencies (US$) in 2009 in Least developed countries to that in Sub-Saharan Africa (all income levels)?
Keep it short and to the point. 0.93. What is the ratio of the Aid flow from UN agencies (US$) in 2010 in Least developed countries to that in Sub-Saharan Africa (all income levels)?
Keep it short and to the point. 1.17. What is the ratio of the Aid flow from UN agencies (US$) in 2007 in Low income to that in Lower middle income?
Keep it short and to the point. 158.17. What is the ratio of the Aid flow from UN agencies (US$) of 2008 in Low income to that in Lower middle income?
Provide a succinct answer. 9.98. What is the ratio of the Aid flow from UN agencies (US$) in 2009 in Low income to that in Lower middle income?
Keep it short and to the point. 8.48. What is the ratio of the Aid flow from UN agencies (US$) of 2010 in Low income to that in Lower middle income?
Offer a very short reply. 8.91. What is the ratio of the Aid flow from UN agencies (US$) in 2007 in Low income to that in Sub-Saharan Africa (all income levels)?
Make the answer very short. 0.99. What is the ratio of the Aid flow from UN agencies (US$) in 2008 in Low income to that in Sub-Saharan Africa (all income levels)?
Your response must be concise. 0.91. What is the ratio of the Aid flow from UN agencies (US$) in 2009 in Low income to that in Sub-Saharan Africa (all income levels)?
Offer a very short reply. 0.94. What is the ratio of the Aid flow from UN agencies (US$) of 2010 in Low income to that in Sub-Saharan Africa (all income levels)?
Your answer should be very brief. 1.11. What is the ratio of the Aid flow from UN agencies (US$) in 2007 in Lower middle income to that in Sub-Saharan Africa (all income levels)?
Your response must be concise. 0.01. What is the ratio of the Aid flow from UN agencies (US$) in 2008 in Lower middle income to that in Sub-Saharan Africa (all income levels)?
Ensure brevity in your answer.  0.09. What is the ratio of the Aid flow from UN agencies (US$) in 2009 in Lower middle income to that in Sub-Saharan Africa (all income levels)?
Provide a succinct answer. 0.11. What is the ratio of the Aid flow from UN agencies (US$) in 2010 in Lower middle income to that in Sub-Saharan Africa (all income levels)?
Make the answer very short. 0.12. What is the difference between the highest and the second highest Aid flow from UN agencies (US$) of 2008?
Offer a terse response. 4.00e+05. What is the difference between the highest and the second highest Aid flow from UN agencies (US$) in 2009?
Offer a terse response. 0. What is the difference between the highest and the second highest Aid flow from UN agencies (US$) in 2010?
Provide a succinct answer. 2.32e+06. What is the difference between the highest and the lowest Aid flow from UN agencies (US$) of 2007?
Provide a short and direct response. 9.49e+06. What is the difference between the highest and the lowest Aid flow from UN agencies (US$) of 2008?
Make the answer very short. 3.05e+07. What is the difference between the highest and the lowest Aid flow from UN agencies (US$) in 2009?
Provide a succinct answer. 3.66e+07. What is the difference between the highest and the lowest Aid flow from UN agencies (US$) in 2010?
Offer a terse response. 4.30e+07. 